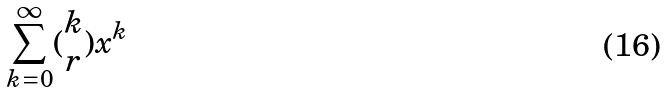Convert formula to latex. <formula><loc_0><loc_0><loc_500><loc_500>\sum _ { k = 0 } ^ { \infty } ( \begin{matrix} k \\ r \end{matrix} ) x ^ { k }</formula> 